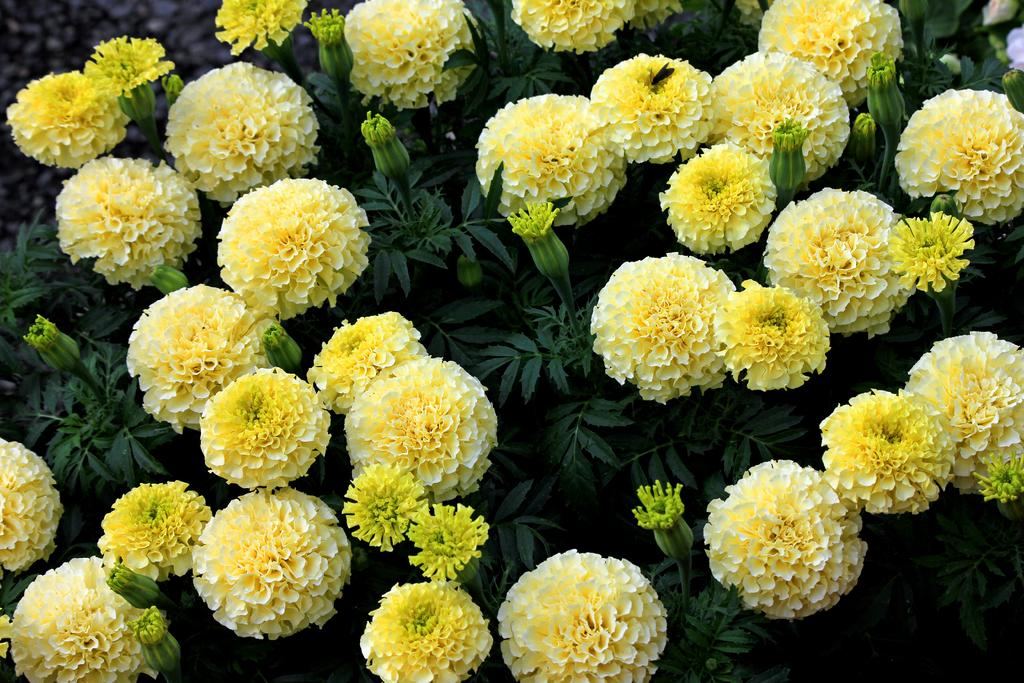What type of plants can be seen in the image? There are flower plants in the image. What color are the flowers on the plants? The flowers are yellow in color. What type of shop can be seen in the image? There is no shop present in the image; it features flower plants with yellow flowers. What day of the week is depicted in the image? The image does not depict a specific day of the week; it only shows flower plants with yellow flowers. 